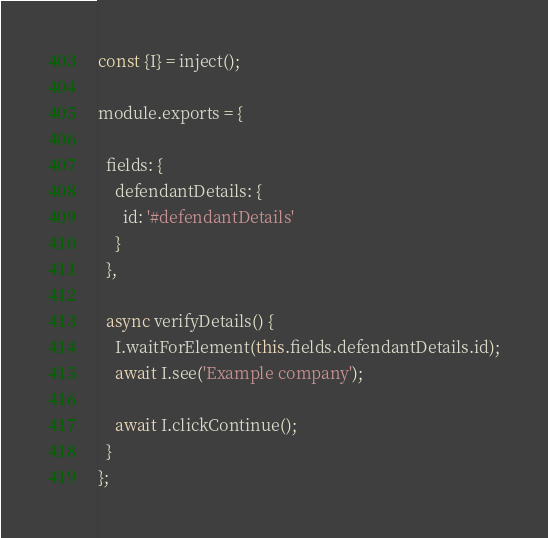Convert code to text. <code><loc_0><loc_0><loc_500><loc_500><_JavaScript_>const {I} = inject();

module.exports = {

  fields: {
    defendantDetails: {
      id: '#defendantDetails'
    }
  },

  async verifyDetails() {
    I.waitForElement(this.fields.defendantDetails.id);
    await I.see('Example company');

    await I.clickContinue();
  }
};

</code> 